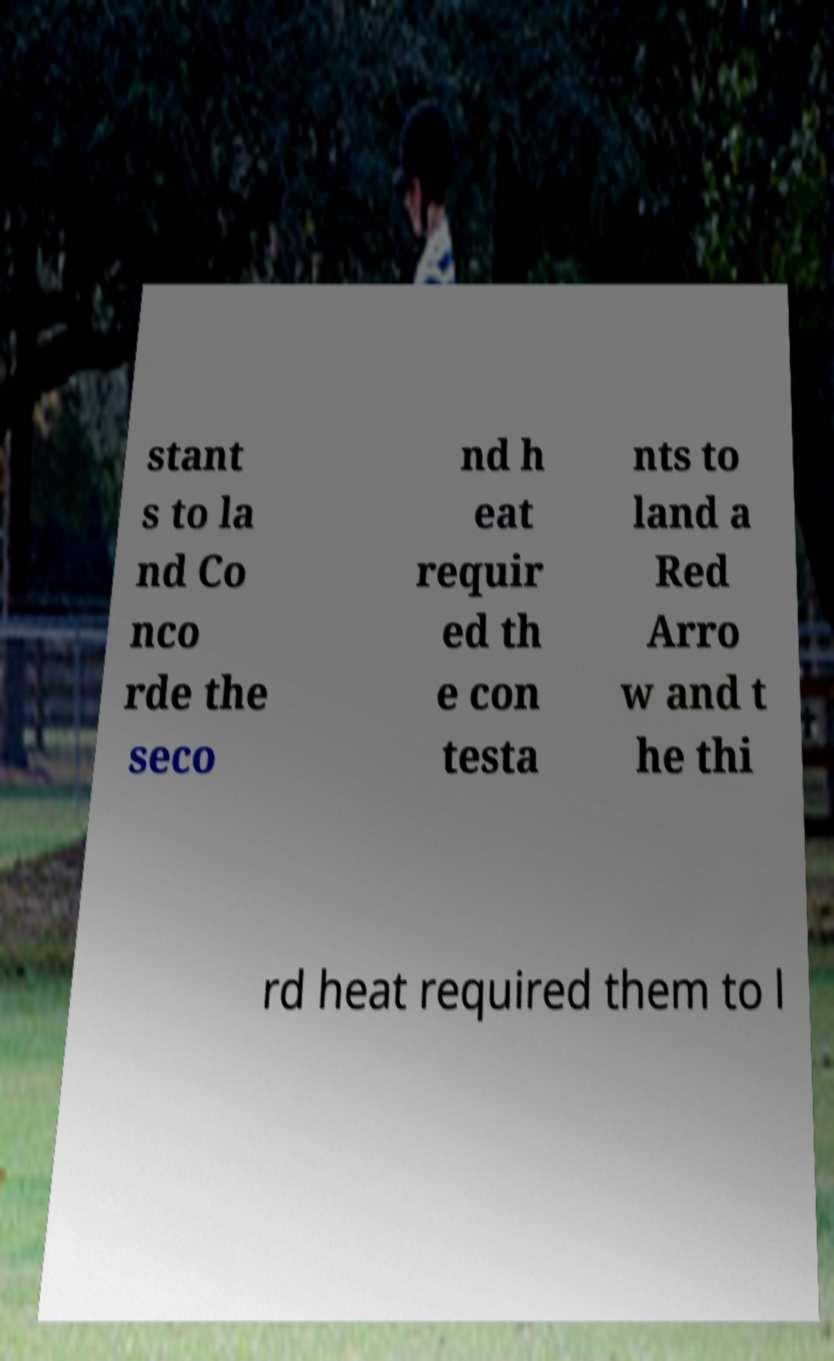Can you read and provide the text displayed in the image?This photo seems to have some interesting text. Can you extract and type it out for me? stant s to la nd Co nco rde the seco nd h eat requir ed th e con testa nts to land a Red Arro w and t he thi rd heat required them to l 